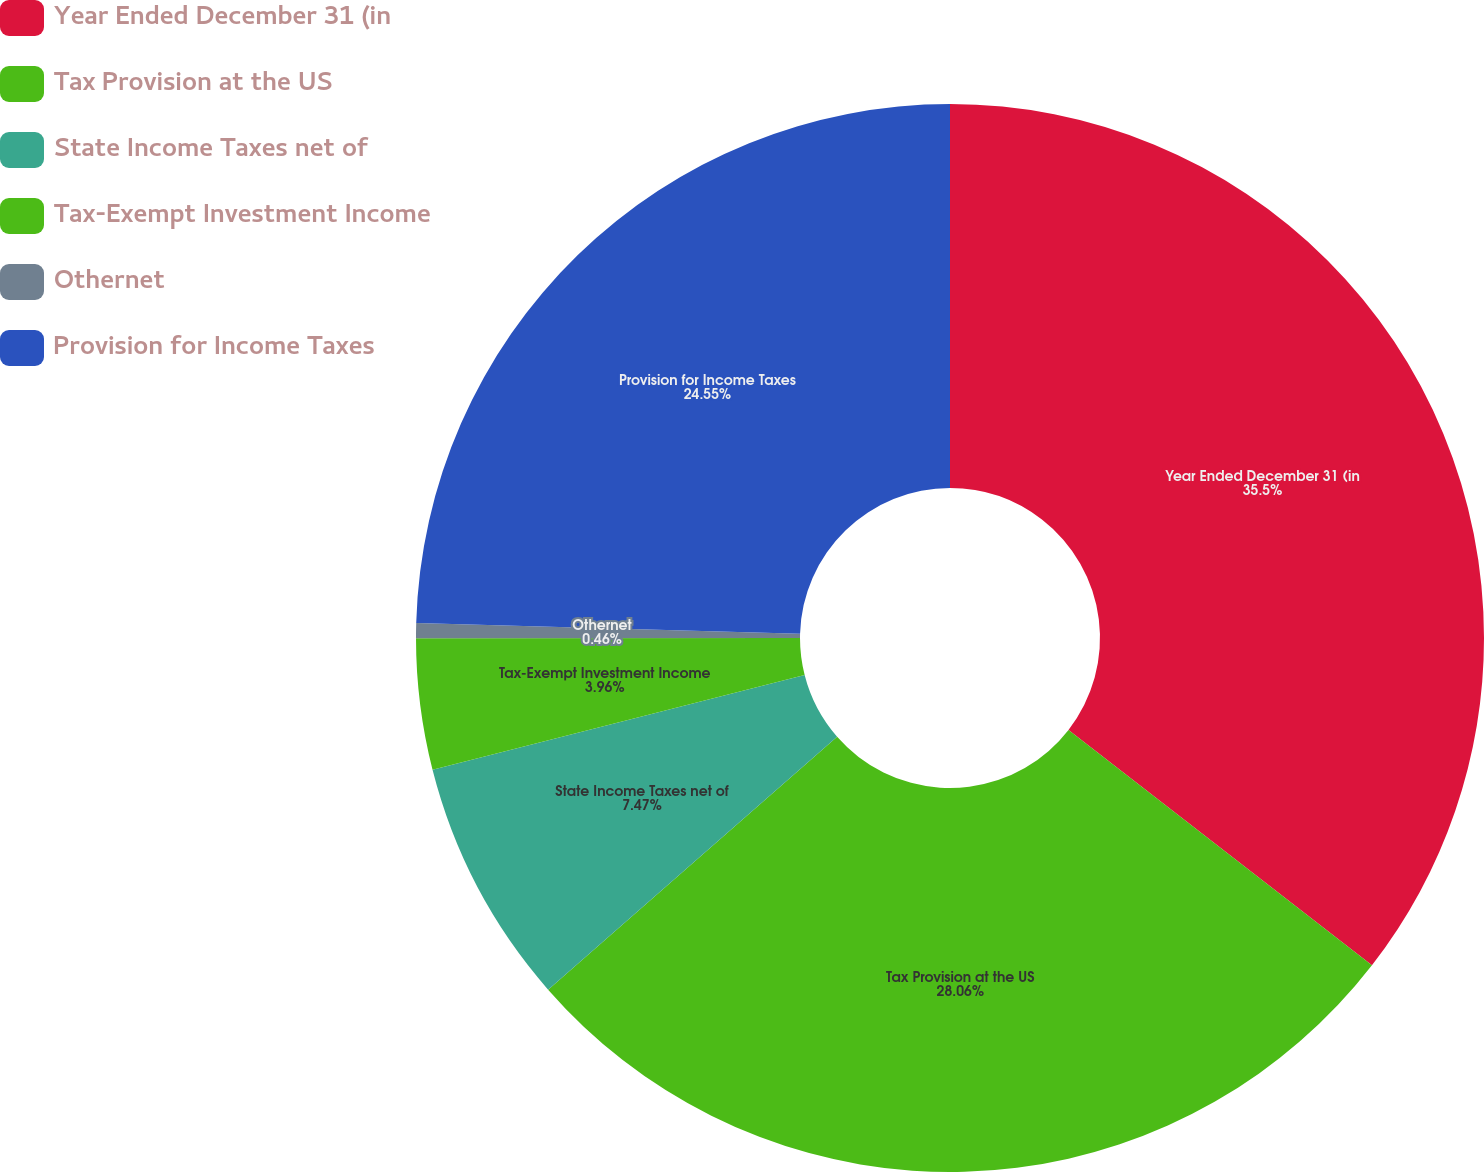<chart> <loc_0><loc_0><loc_500><loc_500><pie_chart><fcel>Year Ended December 31 (in<fcel>Tax Provision at the US<fcel>State Income Taxes net of<fcel>Tax-Exempt Investment Income<fcel>Othernet<fcel>Provision for Income Taxes<nl><fcel>35.5%<fcel>28.06%<fcel>7.47%<fcel>3.96%<fcel>0.46%<fcel>24.55%<nl></chart> 